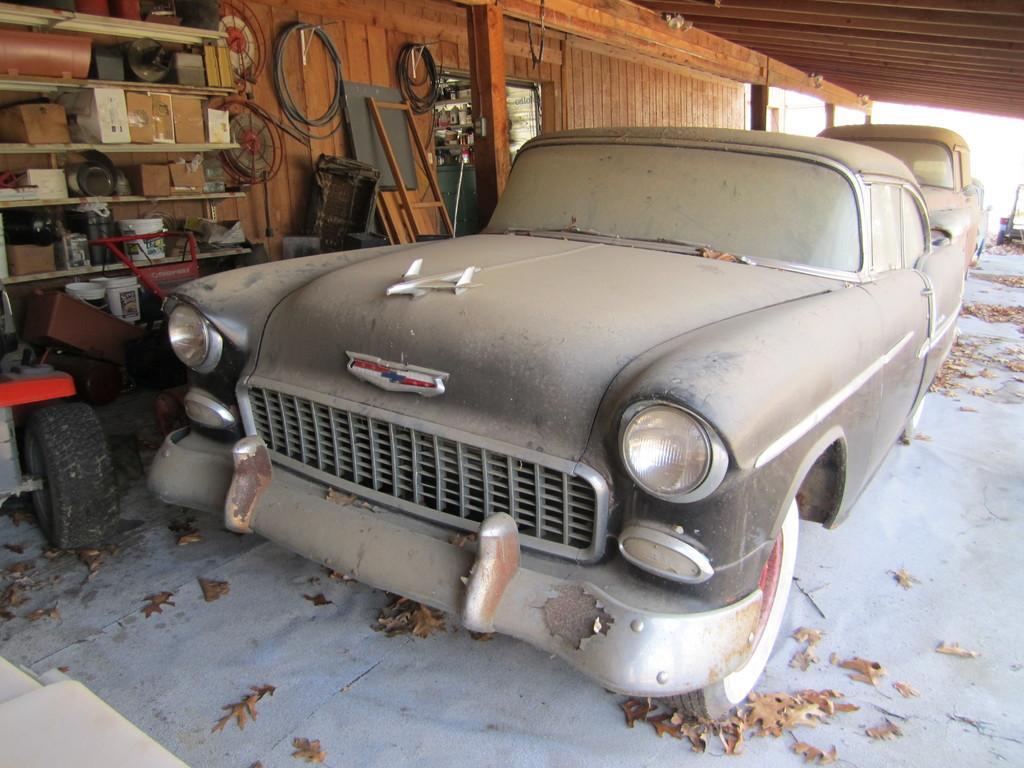How many cars are in the garage in the image? There are two cars in the garage in the image. What is located on the left side of the garage? There is a shelf on the left side of the garage. What items are placed on the shelf? Some buckets are placed on the shelf. What can be seen in the background of the garage? There is a wooden wall in the background of the garage. What type of prose is written on the wooden wall in the background of the garage? There is no prose written on the wooden wall in the background of the garage; it is a plain wooden wall. Can you see a lake in the image? There is no lake present in the image; it is a garage with two cars, a shelf, buckets, and a wooden wall. 